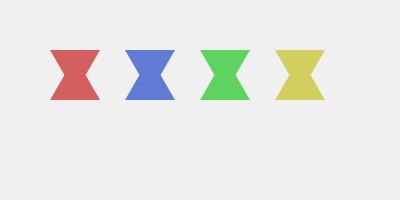Which Baltic folk art pattern is represented in the image above? To identify the traditional Baltic folk art pattern in the image, let's analyze the key characteristics:

1. Shape: The pattern consists of repeated triangular shapes.
2. Arrangement: The triangles are arranged in two rows, with the top row pointing downwards and the bottom row pointing upwards.
3. Color: The pattern uses four distinct colors - red, blue, green, and yellow.
4. Symmetry: The pattern is symmetrical both horizontally and vertically.

These characteristics are typical of the "Auseklis" or "Morning Star" pattern, which is a common motif in Baltic, particularly Latvian, folk art. The Auseklis symbol represents:

- The morning star (planet Venus)
- A sign of protection
- A symbol of cosmic order and harmony

The eight-pointed star formed by the arrangement of triangles is a key identifier of this pattern. In Baltic folklore, the number eight is associated with harmony and balance.

This pattern is often found in traditional textiles, such as mittens, socks, and blankets, as well as in modern interpretations of Baltic design.
Answer: Auseklis (Morning Star) pattern 